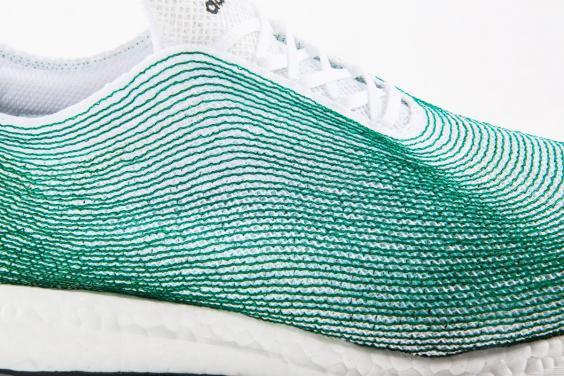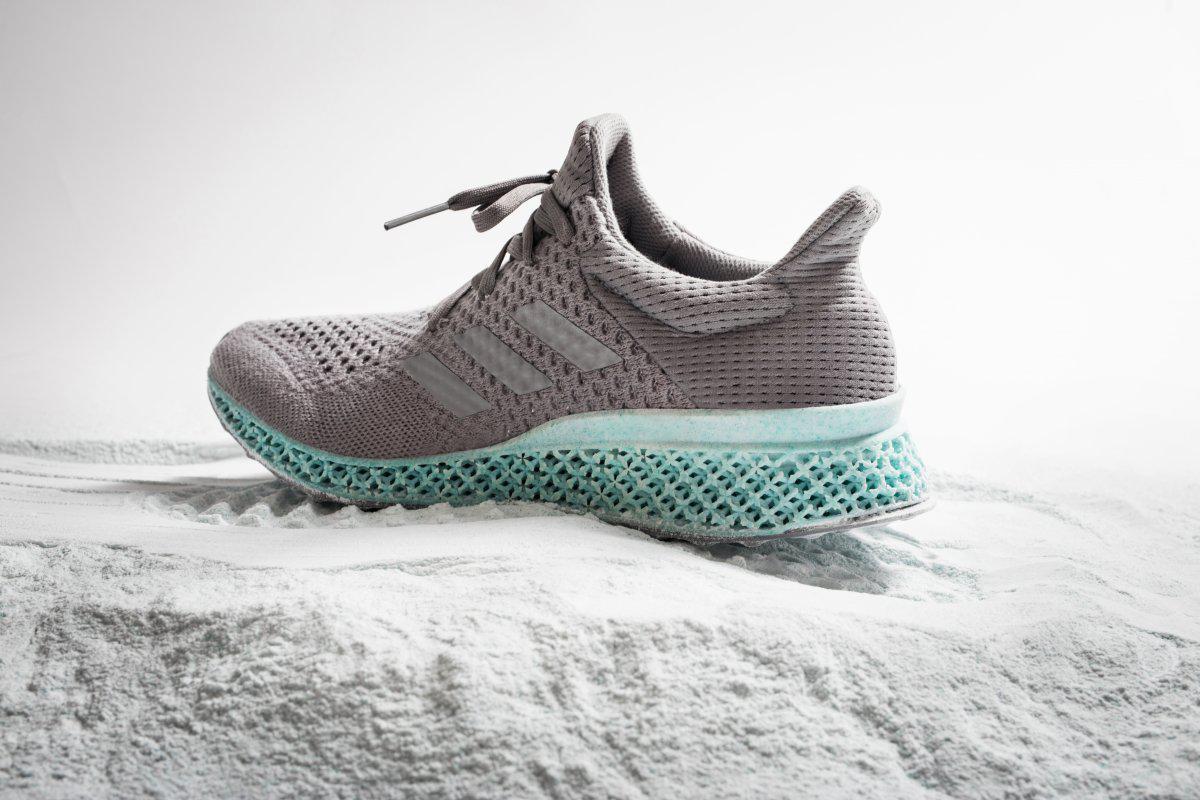The first image is the image on the left, the second image is the image on the right. Evaluate the accuracy of this statement regarding the images: "An image shows blue sneakers posed with a tangle of fibrous strings.". Is it true? Answer yes or no. No. The first image is the image on the left, the second image is the image on the right. Examine the images to the left and right. Is the description "There are more than three shoes." accurate? Answer yes or no. No. 